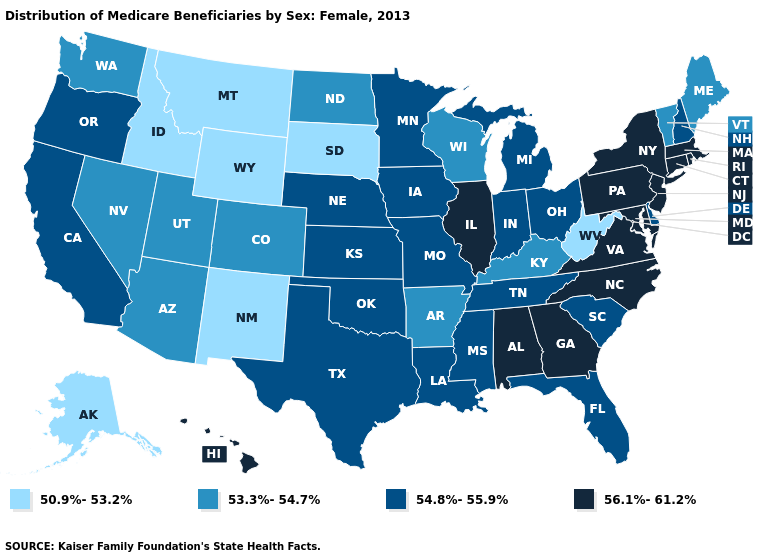Does the first symbol in the legend represent the smallest category?
Keep it brief. Yes. Does the first symbol in the legend represent the smallest category?
Answer briefly. Yes. What is the value of Minnesota?
Keep it brief. 54.8%-55.9%. Which states hav the highest value in the Northeast?
Concise answer only. Connecticut, Massachusetts, New Jersey, New York, Pennsylvania, Rhode Island. What is the highest value in the South ?
Write a very short answer. 56.1%-61.2%. Which states hav the highest value in the West?
Keep it brief. Hawaii. What is the value of Arkansas?
Write a very short answer. 53.3%-54.7%. Among the states that border Kentucky , does West Virginia have the lowest value?
Write a very short answer. Yes. Does the map have missing data?
Short answer required. No. What is the highest value in the USA?
Quick response, please. 56.1%-61.2%. What is the highest value in the USA?
Give a very brief answer. 56.1%-61.2%. Name the states that have a value in the range 53.3%-54.7%?
Short answer required. Arizona, Arkansas, Colorado, Kentucky, Maine, Nevada, North Dakota, Utah, Vermont, Washington, Wisconsin. Which states have the lowest value in the USA?
Quick response, please. Alaska, Idaho, Montana, New Mexico, South Dakota, West Virginia, Wyoming. Name the states that have a value in the range 50.9%-53.2%?
Quick response, please. Alaska, Idaho, Montana, New Mexico, South Dakota, West Virginia, Wyoming. Name the states that have a value in the range 54.8%-55.9%?
Short answer required. California, Delaware, Florida, Indiana, Iowa, Kansas, Louisiana, Michigan, Minnesota, Mississippi, Missouri, Nebraska, New Hampshire, Ohio, Oklahoma, Oregon, South Carolina, Tennessee, Texas. 